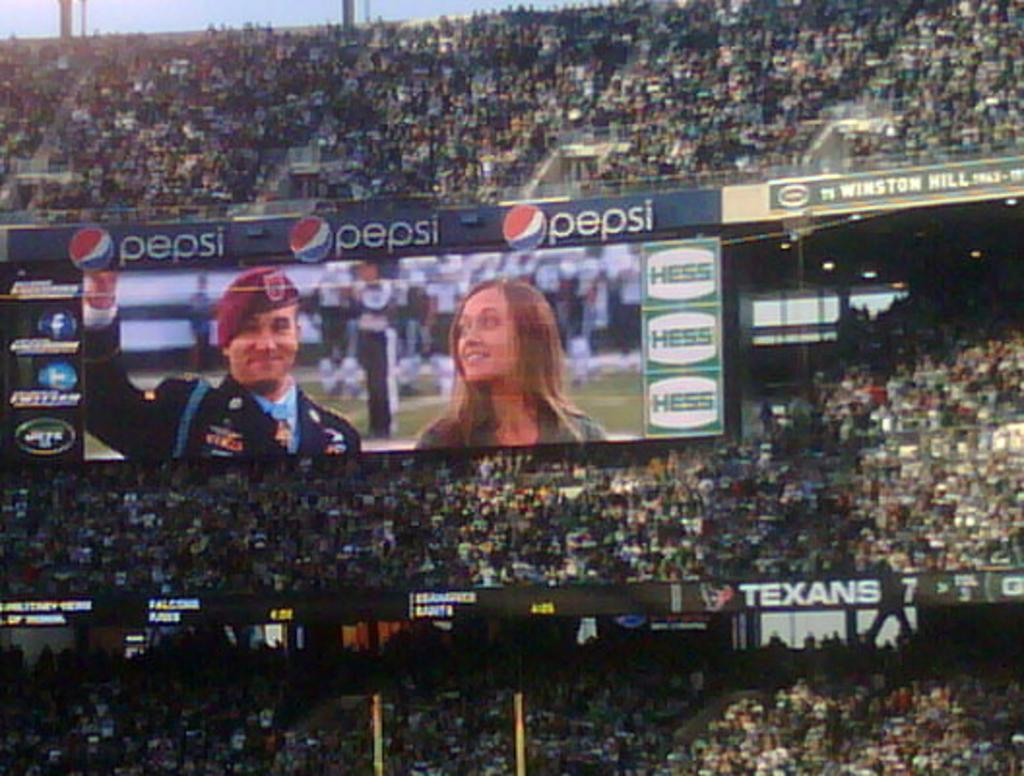Provide a one-sentence caption for the provided image. A stadium full of people sponsored by Pepsi and Hess. 